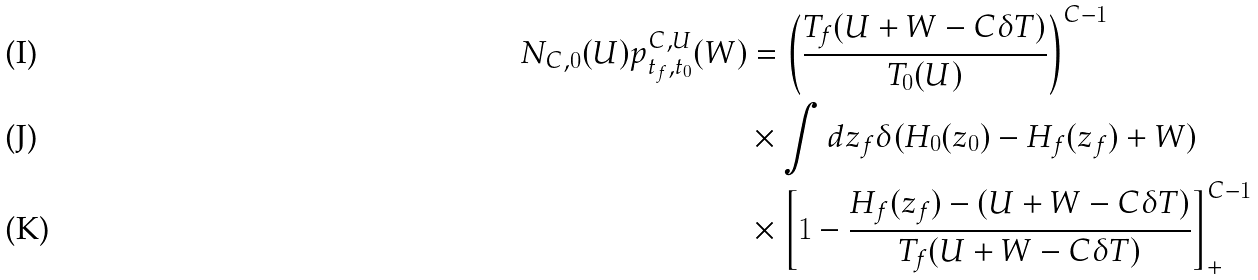<formula> <loc_0><loc_0><loc_500><loc_500>N _ { C , 0 } ( U ) p _ { t _ { f } , t _ { 0 } } ^ { C , U } ( W ) & = \left ( \frac { T _ { f } ( U + W - C \delta T ) } { T _ { 0 } ( U ) } \right ) ^ { C - 1 } \\ & \times \int d z _ { f } \delta ( H _ { 0 } ( z _ { 0 } ) - H _ { f } ( z _ { f } ) + W ) \\ & \times \left [ 1 - \frac { H _ { f } ( z _ { f } ) - ( U + W - C \delta T ) } { T _ { f } ( U + W - C \delta T ) } \right ] ^ { C - 1 } _ { + }</formula> 